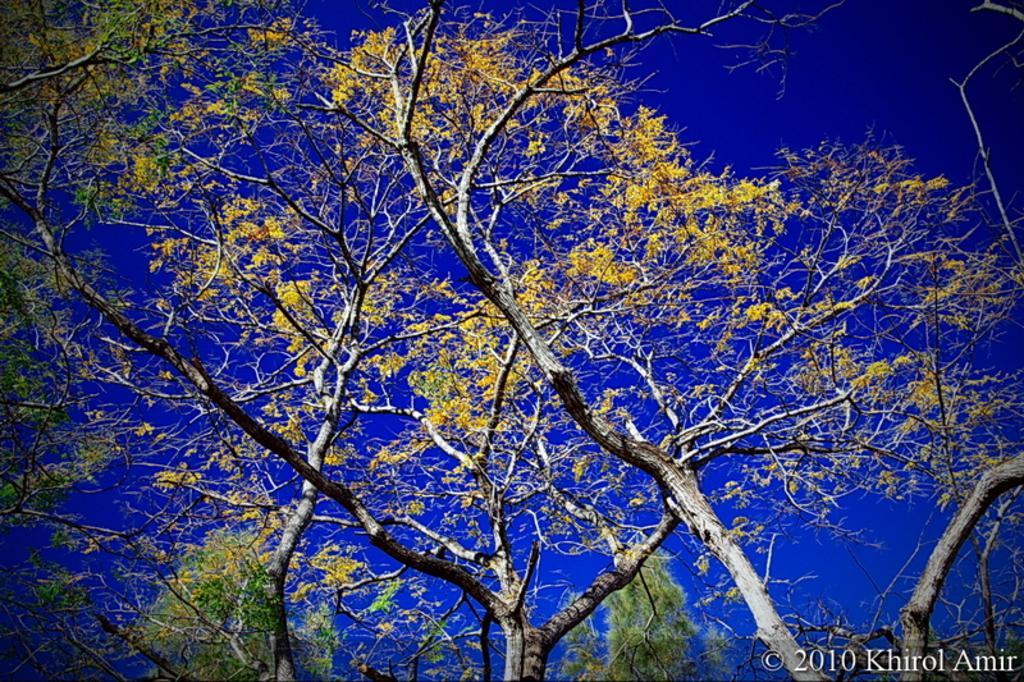Please provide a concise description of this image. In this image there are trees and on the trees there are flowers. 